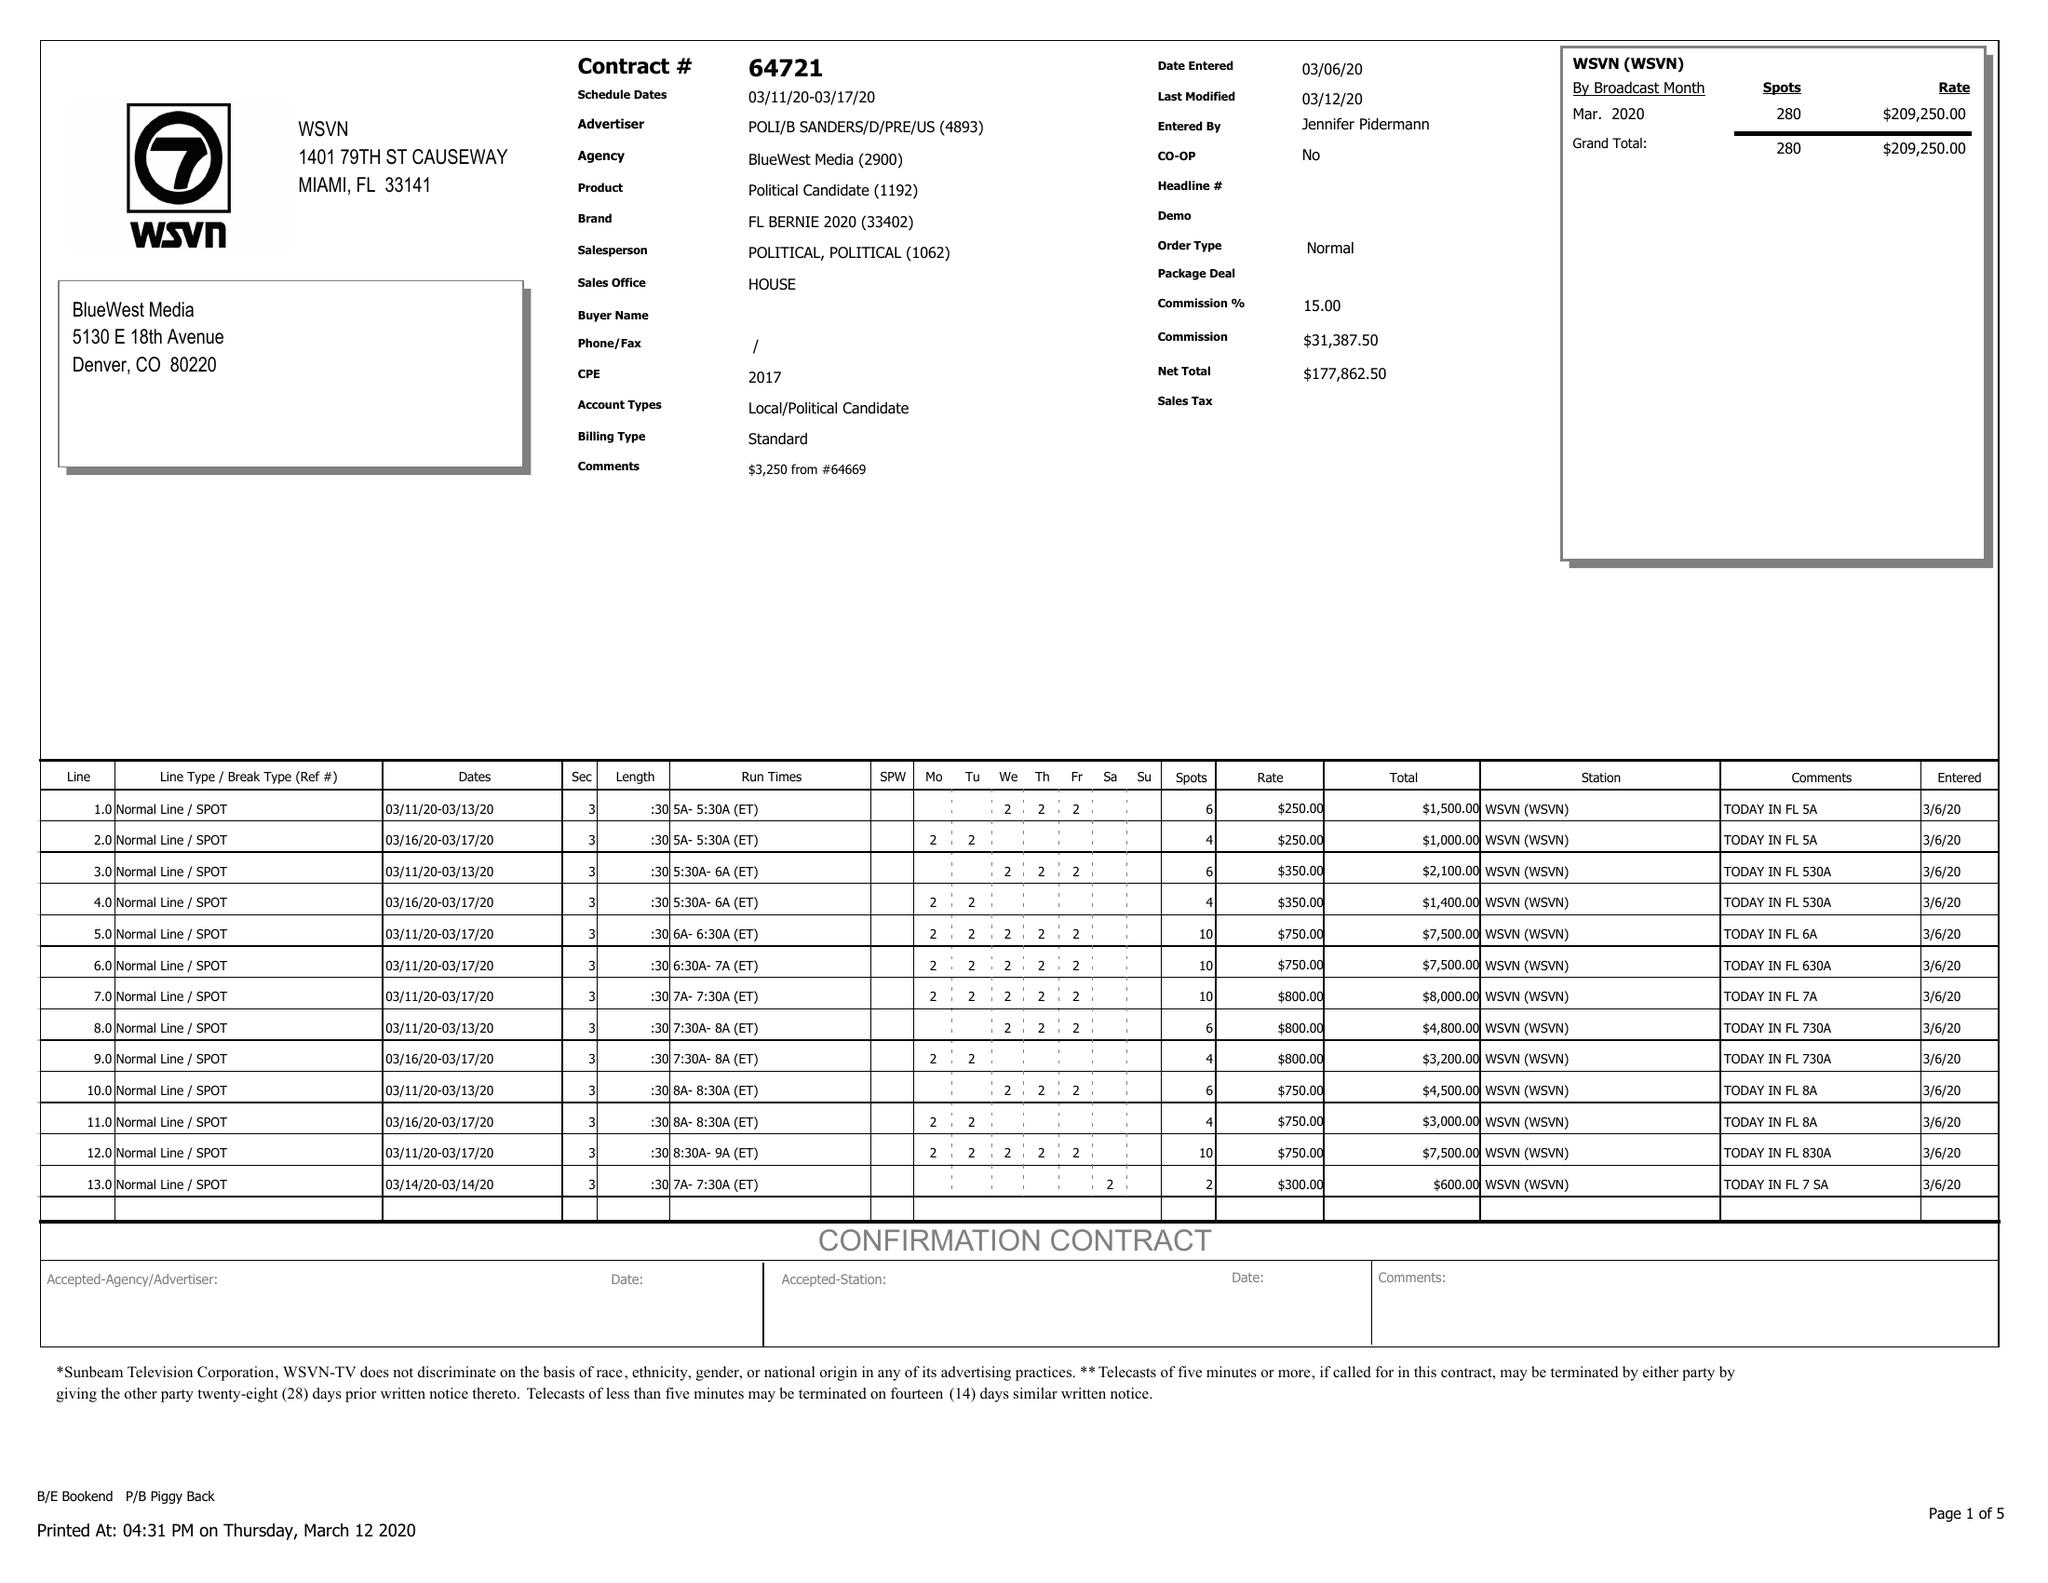What is the value for the gross_amount?
Answer the question using a single word or phrase. 209250.00 